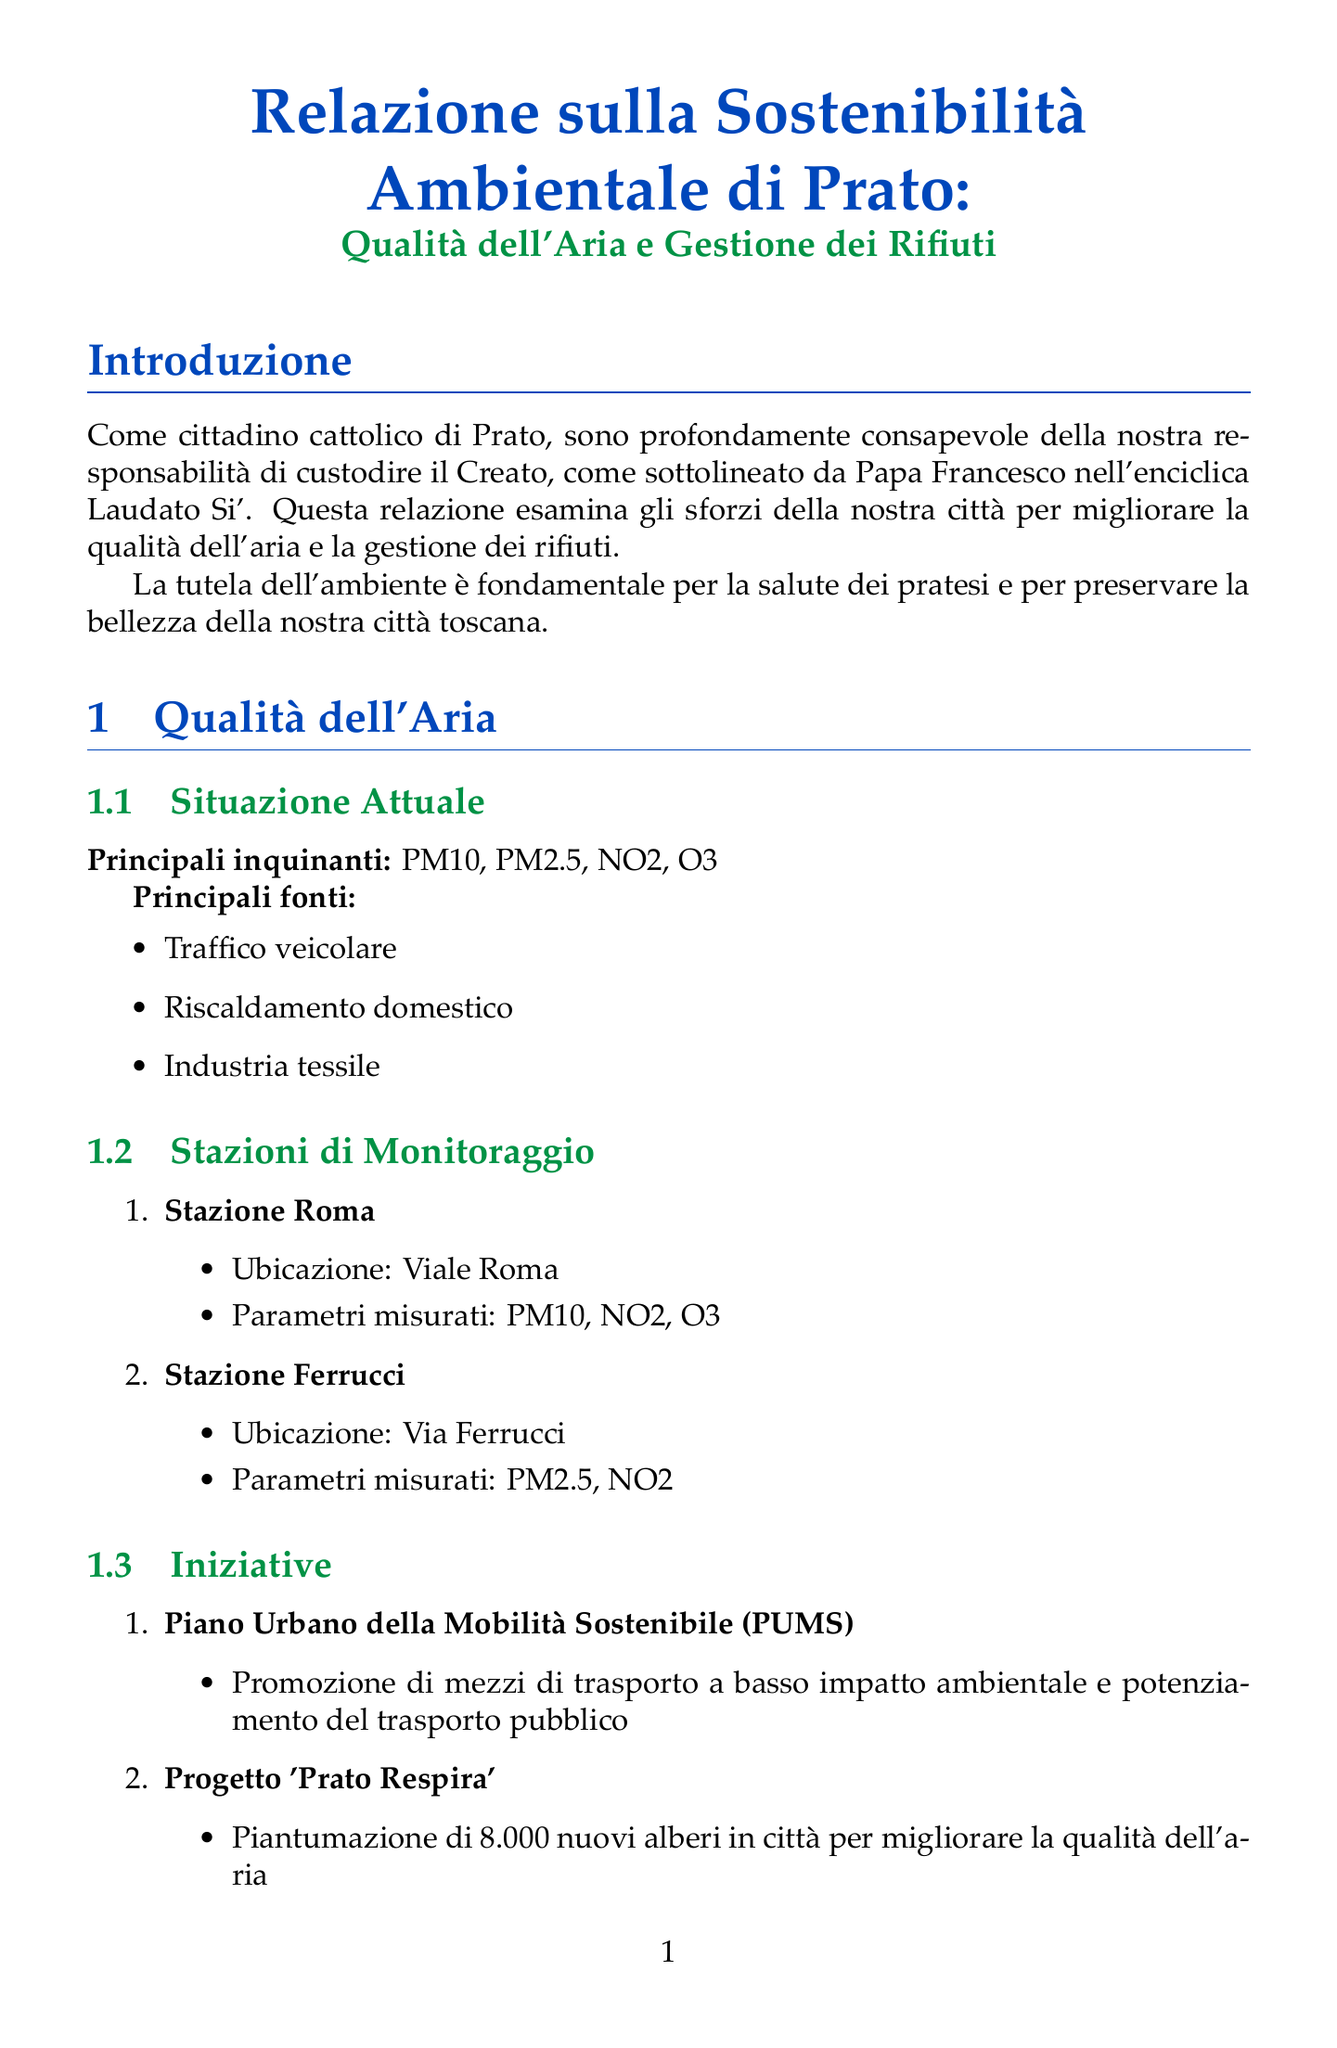Qual è il titolo del rapporto? Il titolo del rapporto è esplicitamente menzionato all'inizio del documento.
Answer: Relazione sulla Sostenibilità Ambientale di Prato: Qualità dell'Aria e Gestione dei Rifiuti Quali sono i principali inquinanti presenti nella qualità dell'aria? I principali inquinanti sono elencati nella sezione sulla qualità dell'aria.
Answer: PM10, PM2.5, NO2, O3 Che percentuale di rifiuti viene riciclata? La percentuale di rifiuti riciclati è specificata nella sezione sulla gestione dei rifiuti.
Answer: 65% Qual è una delle fonti principali di inquinamento dell'aria? Una delle fonti di inquinamento è indicata nella sezione sulla qualità dell'aria.
Answer: Traffico veicolare Quale progetto mira a piantare nuovi alberi a Prato? Il progetto specifico per la piantumazione di alberi è menzionato nella sezione delle iniziative.
Answer: Progetto 'Prato Respira' Qual è l'obiettivo del Piano 'Prato Green 2030'? L'obiettivo del piano è descritto nella sezione Progetti Futuri.
Answer: Strategia decennale per la transizione ecologica della città Qual è la metodologia di raccolta dei rifiuti nella città? La metodologia è dettagliata nella sezione sulla gestione dei rifiuti.
Answer: Raccolta differenziata porta a porta Qual è la sfida principale per la gestione dei rifiuti? La principale sfida è elencata nella sezione dedicata alle sfide per la gestione dei rifiuti.
Answer: Aumento della percentuale di raccolta differenziata al 75% Quanti nuovi alberi sono previsti dal progetto 'Prato Respira'? Il numero di alberi è specificato nella descrizione del progetto nella sezione qualità dell'aria.
Answer: 8.000 